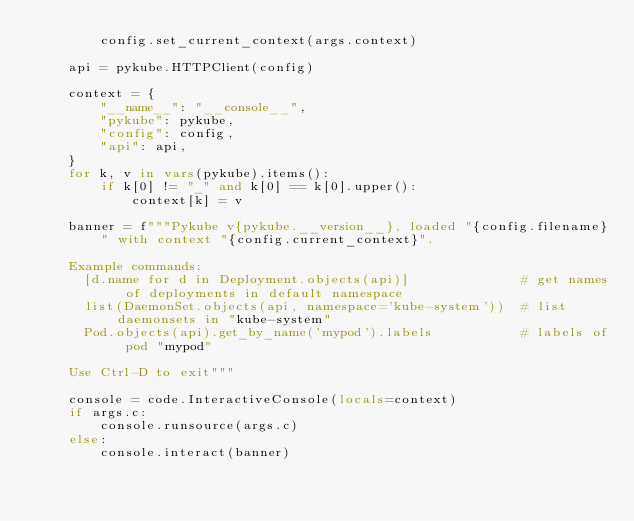Convert code to text. <code><loc_0><loc_0><loc_500><loc_500><_Python_>        config.set_current_context(args.context)

    api = pykube.HTTPClient(config)

    context = {
        "__name__": "__console__",
        "pykube": pykube,
        "config": config,
        "api": api,
    }
    for k, v in vars(pykube).items():
        if k[0] != "_" and k[0] == k[0].upper():
            context[k] = v

    banner = f"""Pykube v{pykube.__version__}, loaded "{config.filename}" with context "{config.current_context}".

    Example commands:
      [d.name for d in Deployment.objects(api)]              # get names of deployments in default namespace
      list(DaemonSet.objects(api, namespace='kube-system'))  # list daemonsets in "kube-system"
      Pod.objects(api).get_by_name('mypod').labels           # labels of pod "mypod"

    Use Ctrl-D to exit"""

    console = code.InteractiveConsole(locals=context)
    if args.c:
        console.runsource(args.c)
    else:
        console.interact(banner)
</code> 